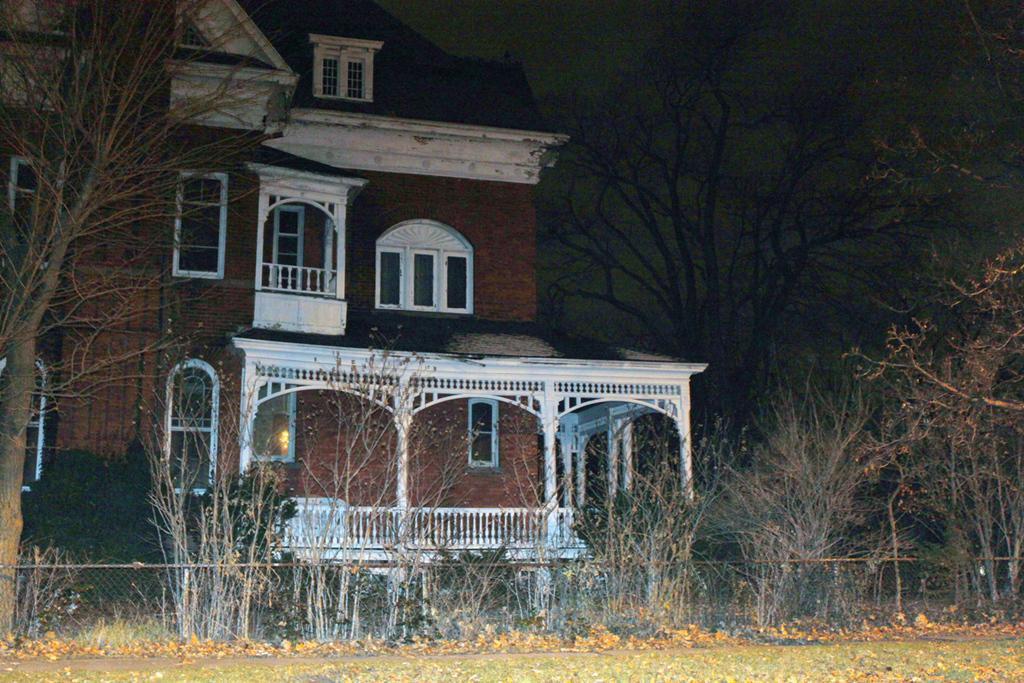In one or two sentences, can you explain what this image depicts? In this image I can see the house with windows and it is brown color. In-front of the house I can see many trees and the railing. 